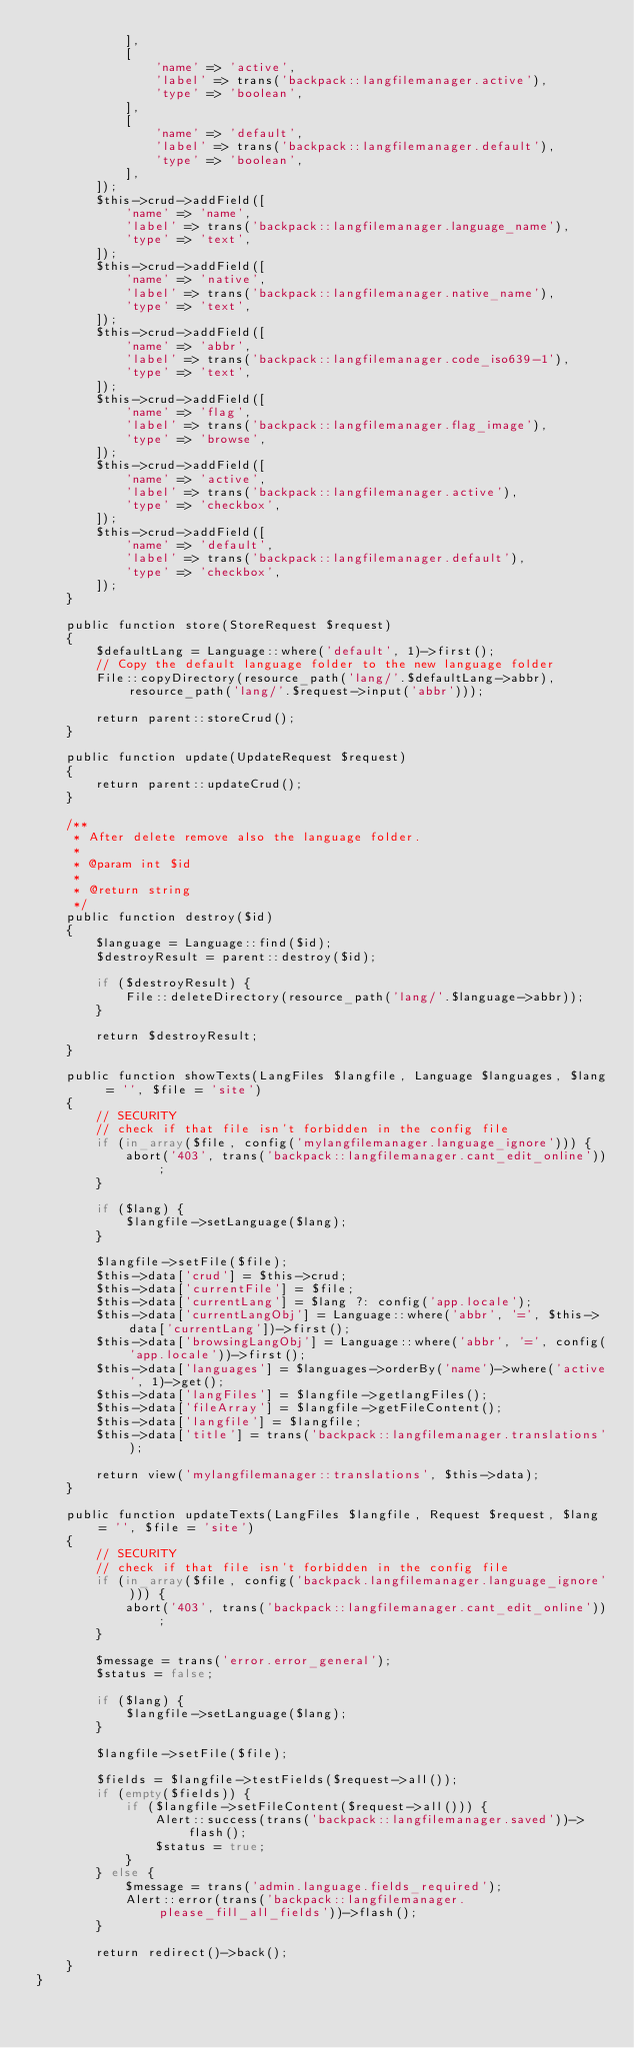Convert code to text. <code><loc_0><loc_0><loc_500><loc_500><_PHP_>            ],
            [
                'name' => 'active',
                'label' => trans('backpack::langfilemanager.active'),
                'type' => 'boolean',
            ],
            [
                'name' => 'default',
                'label' => trans('backpack::langfilemanager.default'),
                'type' => 'boolean',
            ],
        ]);
        $this->crud->addField([
            'name' => 'name',
            'label' => trans('backpack::langfilemanager.language_name'),
            'type' => 'text',
        ]);
        $this->crud->addField([
            'name' => 'native',
            'label' => trans('backpack::langfilemanager.native_name'),
            'type' => 'text',
        ]);
        $this->crud->addField([
            'name' => 'abbr',
            'label' => trans('backpack::langfilemanager.code_iso639-1'),
            'type' => 'text',
        ]);
        $this->crud->addField([
            'name' => 'flag',
            'label' => trans('backpack::langfilemanager.flag_image'),
            'type' => 'browse',
        ]);
        $this->crud->addField([
            'name' => 'active',
            'label' => trans('backpack::langfilemanager.active'),
            'type' => 'checkbox',
        ]);
        $this->crud->addField([
            'name' => 'default',
            'label' => trans('backpack::langfilemanager.default'),
            'type' => 'checkbox',
        ]);
    }

    public function store(StoreRequest $request)
    {
        $defaultLang = Language::where('default', 1)->first();
        // Copy the default language folder to the new language folder
        File::copyDirectory(resource_path('lang/'.$defaultLang->abbr), resource_path('lang/'.$request->input('abbr')));

        return parent::storeCrud();
    }

    public function update(UpdateRequest $request)
    {
        return parent::updateCrud();
    }

    /**
     * After delete remove also the language folder.
     *
     * @param int $id
     *
     * @return string
     */
    public function destroy($id)
    {
        $language = Language::find($id);
        $destroyResult = parent::destroy($id);

        if ($destroyResult) {
            File::deleteDirectory(resource_path('lang/'.$language->abbr));
        }

        return $destroyResult;
    }

    public function showTexts(LangFiles $langfile, Language $languages, $lang = '', $file = 'site')
    {
        // SECURITY
        // check if that file isn't forbidden in the config file
        if (in_array($file, config('mylangfilemanager.language_ignore'))) {
            abort('403', trans('backpack::langfilemanager.cant_edit_online'));
        }

        if ($lang) {
            $langfile->setLanguage($lang);
        }

        $langfile->setFile($file);
        $this->data['crud'] = $this->crud;
        $this->data['currentFile'] = $file;
        $this->data['currentLang'] = $lang ?: config('app.locale');
        $this->data['currentLangObj'] = Language::where('abbr', '=', $this->data['currentLang'])->first();
        $this->data['browsingLangObj'] = Language::where('abbr', '=', config('app.locale'))->first();
        $this->data['languages'] = $languages->orderBy('name')->where('active', 1)->get();
        $this->data['langFiles'] = $langfile->getlangFiles();
        $this->data['fileArray'] = $langfile->getFileContent();
        $this->data['langfile'] = $langfile;
        $this->data['title'] = trans('backpack::langfilemanager.translations');

        return view('mylangfilemanager::translations', $this->data);
    }

    public function updateTexts(LangFiles $langfile, Request $request, $lang = '', $file = 'site')
    {
        // SECURITY
        // check if that file isn't forbidden in the config file
        if (in_array($file, config('backpack.langfilemanager.language_ignore'))) {
            abort('403', trans('backpack::langfilemanager.cant_edit_online'));
        }

        $message = trans('error.error_general');
        $status = false;

        if ($lang) {
            $langfile->setLanguage($lang);
        }

        $langfile->setFile($file);

        $fields = $langfile->testFields($request->all());
        if (empty($fields)) {
            if ($langfile->setFileContent($request->all())) {
                Alert::success(trans('backpack::langfilemanager.saved'))->flash();
                $status = true;
            }
        } else {
            $message = trans('admin.language.fields_required');
            Alert::error(trans('backpack::langfilemanager.please_fill_all_fields'))->flash();
        }

        return redirect()->back();
    }
}
</code> 